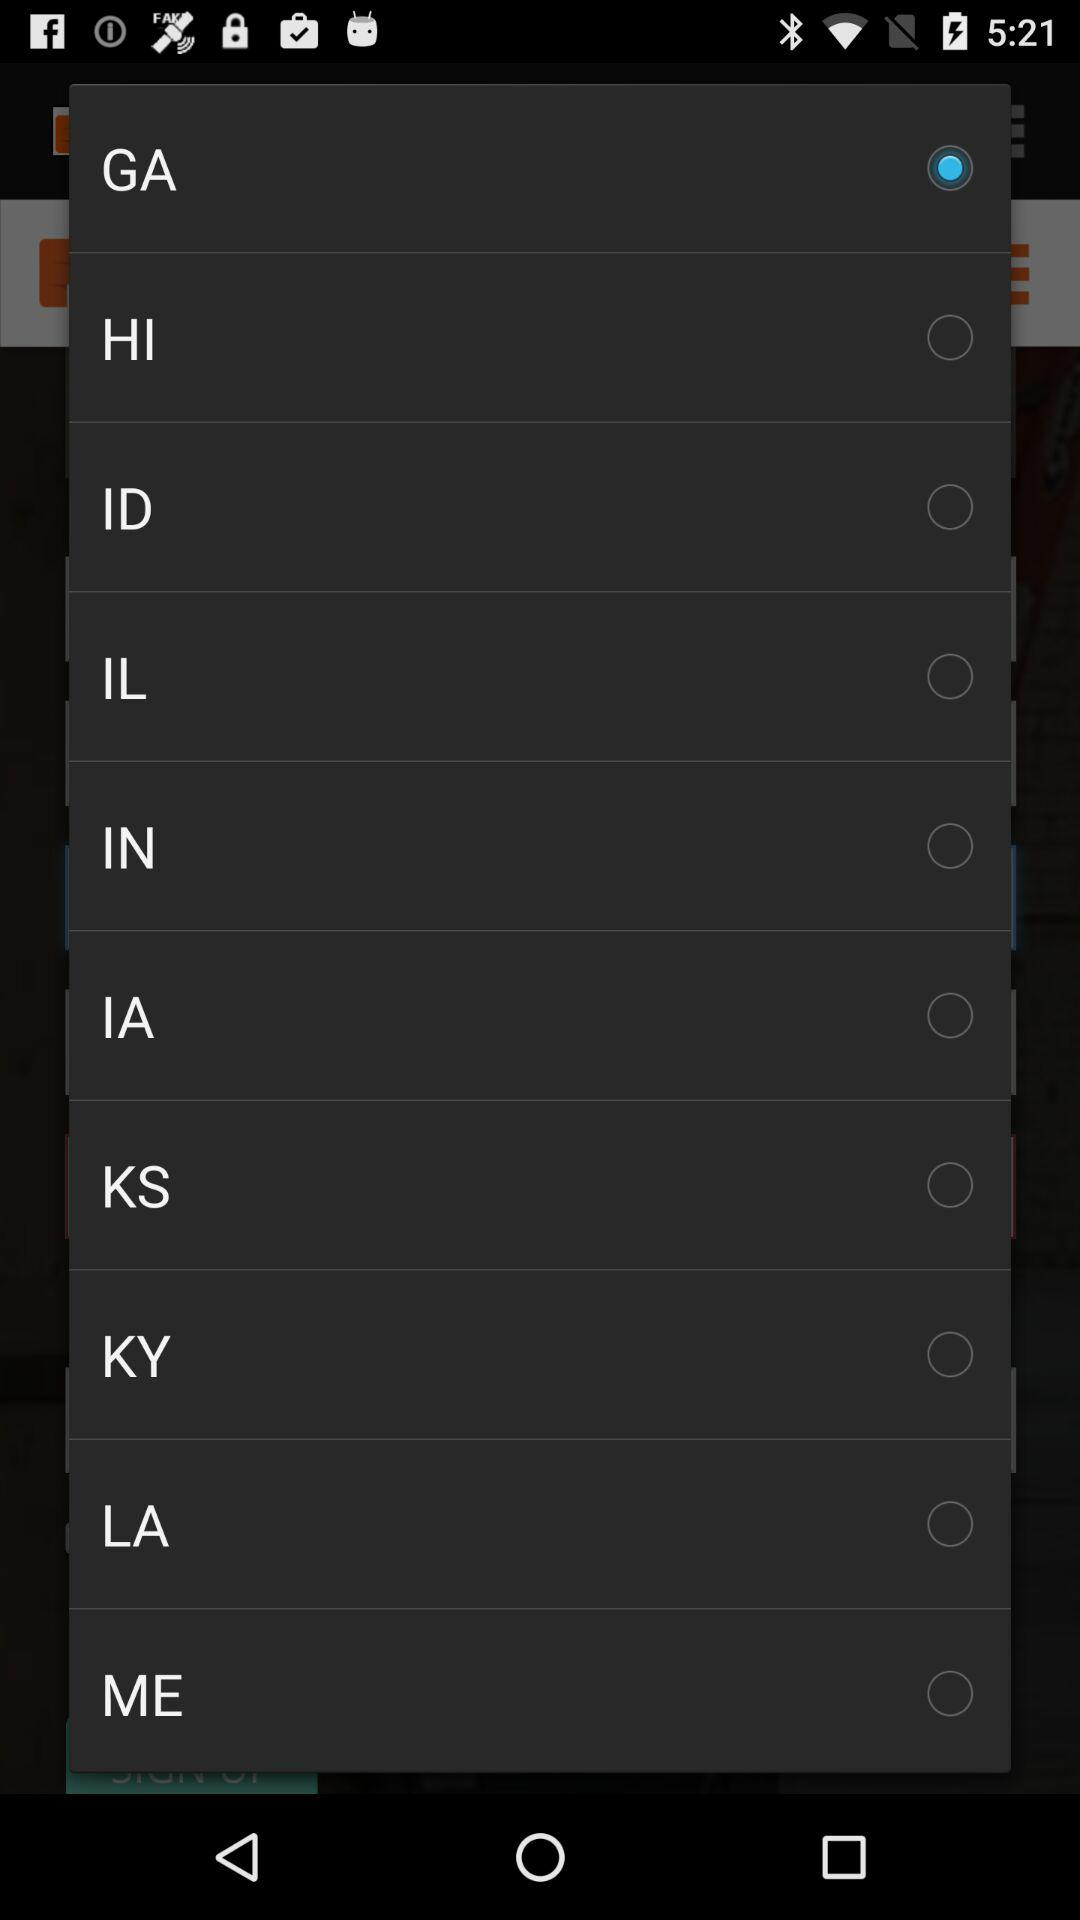Which option is selected? The selected option is "GA". 